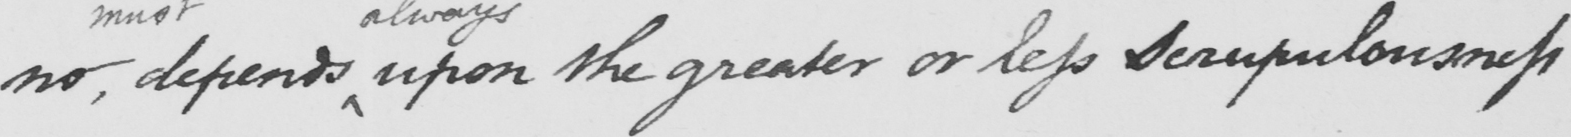Please provide the text content of this handwritten line. no , depends upon the greater or less scrupulousness 